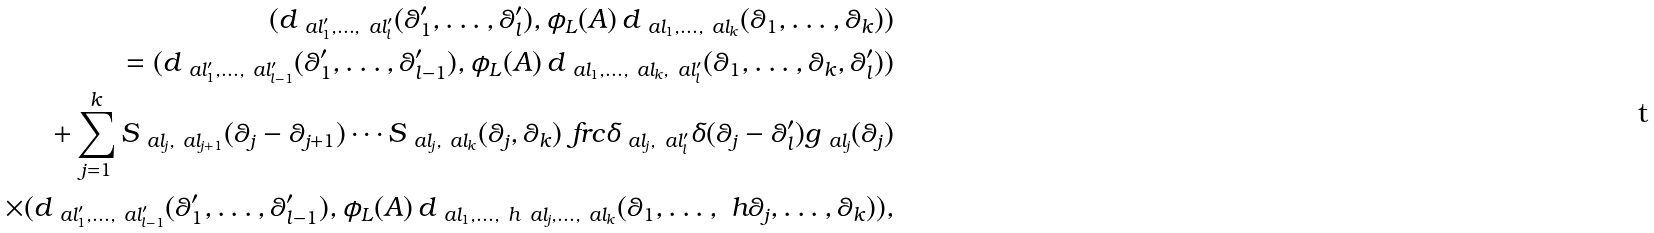Convert formula to latex. <formula><loc_0><loc_0><loc_500><loc_500>( d _ { \ a l _ { 1 } ^ { \prime } , \dots , \ a l _ { l } ^ { \prime } } ( \theta _ { 1 } ^ { \prime } , \dots , \theta _ { l } ^ { \prime } ) , \phi _ { L } ( A ) \, d _ { \ a l _ { 1 } , \dots , \ a l _ { k } } ( \theta _ { 1 } , \dots , \theta _ { k } ) ) \\ = ( d _ { \ a l _ { 1 } ^ { \prime } , \dots , \ a l _ { l - 1 } ^ { \prime } } ( \theta _ { 1 } ^ { \prime } , \dots , \theta _ { l - 1 } ^ { \prime } ) , \phi _ { L } ( A ) \, d _ { \ a l _ { 1 } , \dots , \ a l _ { k } , \ a l _ { l } ^ { \prime } } ( \theta _ { 1 } , \dots , \theta _ { k } , \theta _ { l } ^ { \prime } ) ) \\ + \sum _ { j = 1 } ^ { k } S _ { \ a l _ { j } , \ a l _ { j + 1 } } ( \theta _ { j } - \theta _ { j + 1 } ) \cdots S _ { \ a l _ { j } , \ a l _ { k } } ( \theta _ { j } , \theta _ { k } ) \ f r c { \delta _ { \ a l _ { j } , \ a l _ { l } ^ { \prime } } \delta ( \theta _ { j } - \theta _ { l } ^ { \prime } ) } { g _ { \ a l _ { j } } ( \theta _ { j } ) } \\ \times ( d _ { \ a l _ { 1 } ^ { \prime } , \dots , \ a l _ { l - 1 } ^ { \prime } } ( \theta _ { 1 } ^ { \prime } , \dots , \theta _ { l - 1 } ^ { \prime } ) , \phi _ { L } ( A ) \, d _ { \ a l _ { 1 } , \dots , \ h \ a l _ { j } , \dots , \ a l _ { k } } ( \theta _ { 1 } , \dots , \ h \theta _ { j } , \dots , \theta _ { k } ) ) ,</formula> 